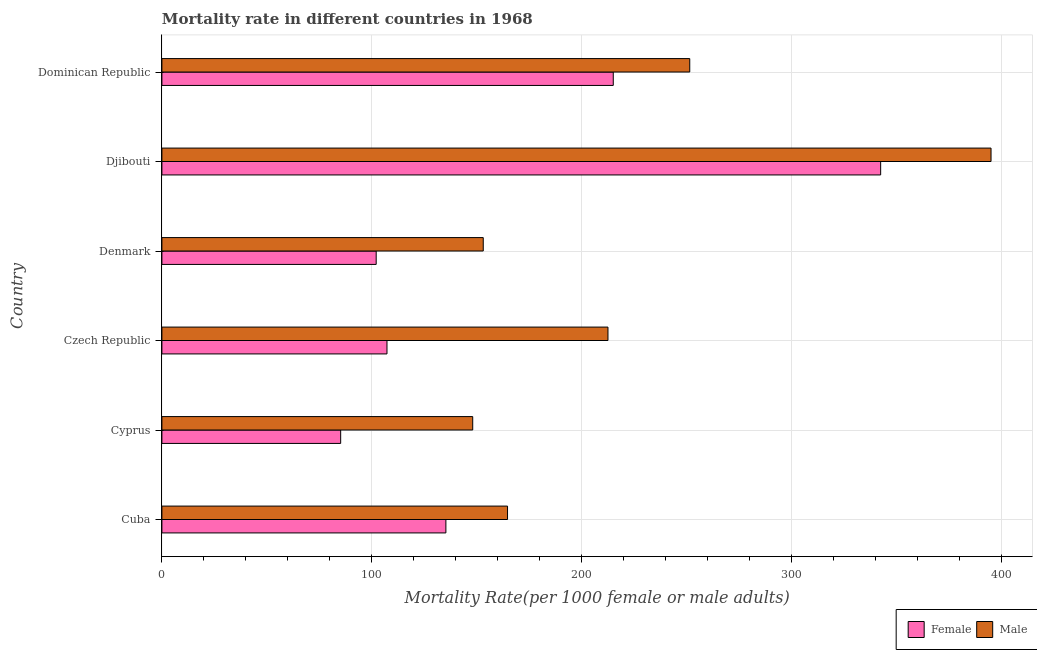How many different coloured bars are there?
Your answer should be compact. 2. How many bars are there on the 5th tick from the bottom?
Make the answer very short. 2. What is the label of the 6th group of bars from the top?
Your answer should be compact. Cuba. In how many cases, is the number of bars for a given country not equal to the number of legend labels?
Provide a short and direct response. 0. What is the female mortality rate in Dominican Republic?
Your answer should be compact. 215.01. Across all countries, what is the maximum female mortality rate?
Your answer should be very brief. 342.39. Across all countries, what is the minimum male mortality rate?
Provide a short and direct response. 148.06. In which country was the female mortality rate maximum?
Provide a short and direct response. Djibouti. In which country was the female mortality rate minimum?
Offer a terse response. Cyprus. What is the total female mortality rate in the graph?
Provide a short and direct response. 987.14. What is the difference between the female mortality rate in Denmark and that in Dominican Republic?
Offer a terse response. -112.94. What is the difference between the female mortality rate in Cyprus and the male mortality rate in Djibouti?
Your answer should be very brief. -309.81. What is the average female mortality rate per country?
Make the answer very short. 164.52. What is the difference between the male mortality rate and female mortality rate in Dominican Republic?
Your response must be concise. 36.43. In how many countries, is the male mortality rate greater than 360 ?
Offer a very short reply. 1. What is the ratio of the male mortality rate in Cyprus to that in Czech Republic?
Ensure brevity in your answer.  0.7. Is the female mortality rate in Cyprus less than that in Czech Republic?
Provide a succinct answer. Yes. Is the difference between the male mortality rate in Czech Republic and Djibouti greater than the difference between the female mortality rate in Czech Republic and Djibouti?
Keep it short and to the point. Yes. What is the difference between the highest and the second highest female mortality rate?
Keep it short and to the point. 127.38. What is the difference between the highest and the lowest male mortality rate?
Offer a terse response. 246.91. In how many countries, is the male mortality rate greater than the average male mortality rate taken over all countries?
Keep it short and to the point. 2. Is the sum of the female mortality rate in Cyprus and Djibouti greater than the maximum male mortality rate across all countries?
Keep it short and to the point. Yes. What does the 2nd bar from the bottom in Dominican Republic represents?
Offer a very short reply. Male. Are all the bars in the graph horizontal?
Your answer should be very brief. Yes. How many countries are there in the graph?
Make the answer very short. 6. What is the difference between two consecutive major ticks on the X-axis?
Offer a terse response. 100. Are the values on the major ticks of X-axis written in scientific E-notation?
Provide a succinct answer. No. Does the graph contain grids?
Your answer should be compact. Yes. How many legend labels are there?
Keep it short and to the point. 2. What is the title of the graph?
Your answer should be very brief. Mortality rate in different countries in 1968. Does "Under-5(female)" appear as one of the legend labels in the graph?
Ensure brevity in your answer.  No. What is the label or title of the X-axis?
Offer a very short reply. Mortality Rate(per 1000 female or male adults). What is the label or title of the Y-axis?
Your answer should be compact. Country. What is the Mortality Rate(per 1000 female or male adults) in Female in Cuba?
Provide a succinct answer. 135.28. What is the Mortality Rate(per 1000 female or male adults) in Male in Cuba?
Your answer should be very brief. 164.65. What is the Mortality Rate(per 1000 female or male adults) of Female in Cyprus?
Ensure brevity in your answer.  85.16. What is the Mortality Rate(per 1000 female or male adults) in Male in Cyprus?
Keep it short and to the point. 148.06. What is the Mortality Rate(per 1000 female or male adults) in Female in Czech Republic?
Ensure brevity in your answer.  107.22. What is the Mortality Rate(per 1000 female or male adults) in Male in Czech Republic?
Give a very brief answer. 212.49. What is the Mortality Rate(per 1000 female or male adults) of Female in Denmark?
Provide a short and direct response. 102.08. What is the Mortality Rate(per 1000 female or male adults) of Male in Denmark?
Your response must be concise. 153.08. What is the Mortality Rate(per 1000 female or male adults) in Female in Djibouti?
Your answer should be very brief. 342.39. What is the Mortality Rate(per 1000 female or male adults) of Male in Djibouti?
Provide a succinct answer. 394.97. What is the Mortality Rate(per 1000 female or male adults) in Female in Dominican Republic?
Give a very brief answer. 215.01. What is the Mortality Rate(per 1000 female or male adults) in Male in Dominican Republic?
Your answer should be compact. 251.44. Across all countries, what is the maximum Mortality Rate(per 1000 female or male adults) of Female?
Make the answer very short. 342.39. Across all countries, what is the maximum Mortality Rate(per 1000 female or male adults) of Male?
Provide a short and direct response. 394.97. Across all countries, what is the minimum Mortality Rate(per 1000 female or male adults) of Female?
Keep it short and to the point. 85.16. Across all countries, what is the minimum Mortality Rate(per 1000 female or male adults) of Male?
Offer a very short reply. 148.06. What is the total Mortality Rate(per 1000 female or male adults) of Female in the graph?
Offer a terse response. 987.14. What is the total Mortality Rate(per 1000 female or male adults) in Male in the graph?
Your answer should be compact. 1324.7. What is the difference between the Mortality Rate(per 1000 female or male adults) of Female in Cuba and that in Cyprus?
Keep it short and to the point. 50.12. What is the difference between the Mortality Rate(per 1000 female or male adults) of Male in Cuba and that in Cyprus?
Provide a succinct answer. 16.59. What is the difference between the Mortality Rate(per 1000 female or male adults) of Female in Cuba and that in Czech Republic?
Make the answer very short. 28.06. What is the difference between the Mortality Rate(per 1000 female or male adults) in Male in Cuba and that in Czech Republic?
Provide a succinct answer. -47.84. What is the difference between the Mortality Rate(per 1000 female or male adults) in Female in Cuba and that in Denmark?
Offer a very short reply. 33.2. What is the difference between the Mortality Rate(per 1000 female or male adults) in Male in Cuba and that in Denmark?
Make the answer very short. 11.57. What is the difference between the Mortality Rate(per 1000 female or male adults) in Female in Cuba and that in Djibouti?
Ensure brevity in your answer.  -207.11. What is the difference between the Mortality Rate(per 1000 female or male adults) in Male in Cuba and that in Djibouti?
Make the answer very short. -230.32. What is the difference between the Mortality Rate(per 1000 female or male adults) in Female in Cuba and that in Dominican Republic?
Provide a short and direct response. -79.73. What is the difference between the Mortality Rate(per 1000 female or male adults) of Male in Cuba and that in Dominican Republic?
Provide a succinct answer. -86.8. What is the difference between the Mortality Rate(per 1000 female or male adults) of Female in Cyprus and that in Czech Republic?
Offer a terse response. -22.07. What is the difference between the Mortality Rate(per 1000 female or male adults) in Male in Cyprus and that in Czech Republic?
Your answer should be very brief. -64.43. What is the difference between the Mortality Rate(per 1000 female or male adults) of Female in Cyprus and that in Denmark?
Offer a terse response. -16.92. What is the difference between the Mortality Rate(per 1000 female or male adults) of Male in Cyprus and that in Denmark?
Provide a succinct answer. -5.02. What is the difference between the Mortality Rate(per 1000 female or male adults) of Female in Cyprus and that in Djibouti?
Ensure brevity in your answer.  -257.23. What is the difference between the Mortality Rate(per 1000 female or male adults) of Male in Cyprus and that in Djibouti?
Your answer should be very brief. -246.91. What is the difference between the Mortality Rate(per 1000 female or male adults) in Female in Cyprus and that in Dominican Republic?
Your answer should be very brief. -129.86. What is the difference between the Mortality Rate(per 1000 female or male adults) of Male in Cyprus and that in Dominican Republic?
Ensure brevity in your answer.  -103.39. What is the difference between the Mortality Rate(per 1000 female or male adults) of Female in Czech Republic and that in Denmark?
Provide a short and direct response. 5.15. What is the difference between the Mortality Rate(per 1000 female or male adults) in Male in Czech Republic and that in Denmark?
Make the answer very short. 59.41. What is the difference between the Mortality Rate(per 1000 female or male adults) in Female in Czech Republic and that in Djibouti?
Your answer should be compact. -235.17. What is the difference between the Mortality Rate(per 1000 female or male adults) of Male in Czech Republic and that in Djibouti?
Provide a succinct answer. -182.48. What is the difference between the Mortality Rate(per 1000 female or male adults) in Female in Czech Republic and that in Dominican Republic?
Provide a succinct answer. -107.79. What is the difference between the Mortality Rate(per 1000 female or male adults) of Male in Czech Republic and that in Dominican Republic?
Ensure brevity in your answer.  -38.95. What is the difference between the Mortality Rate(per 1000 female or male adults) in Female in Denmark and that in Djibouti?
Your answer should be compact. -240.31. What is the difference between the Mortality Rate(per 1000 female or male adults) of Male in Denmark and that in Djibouti?
Ensure brevity in your answer.  -241.89. What is the difference between the Mortality Rate(per 1000 female or male adults) of Female in Denmark and that in Dominican Republic?
Ensure brevity in your answer.  -112.94. What is the difference between the Mortality Rate(per 1000 female or male adults) of Male in Denmark and that in Dominican Republic?
Provide a short and direct response. -98.36. What is the difference between the Mortality Rate(per 1000 female or male adults) in Female in Djibouti and that in Dominican Republic?
Offer a very short reply. 127.38. What is the difference between the Mortality Rate(per 1000 female or male adults) in Male in Djibouti and that in Dominican Republic?
Give a very brief answer. 143.53. What is the difference between the Mortality Rate(per 1000 female or male adults) of Female in Cuba and the Mortality Rate(per 1000 female or male adults) of Male in Cyprus?
Your answer should be very brief. -12.78. What is the difference between the Mortality Rate(per 1000 female or male adults) of Female in Cuba and the Mortality Rate(per 1000 female or male adults) of Male in Czech Republic?
Ensure brevity in your answer.  -77.21. What is the difference between the Mortality Rate(per 1000 female or male adults) of Female in Cuba and the Mortality Rate(per 1000 female or male adults) of Male in Denmark?
Your answer should be very brief. -17.8. What is the difference between the Mortality Rate(per 1000 female or male adults) in Female in Cuba and the Mortality Rate(per 1000 female or male adults) in Male in Djibouti?
Keep it short and to the point. -259.69. What is the difference between the Mortality Rate(per 1000 female or male adults) of Female in Cuba and the Mortality Rate(per 1000 female or male adults) of Male in Dominican Republic?
Offer a terse response. -116.16. What is the difference between the Mortality Rate(per 1000 female or male adults) of Female in Cyprus and the Mortality Rate(per 1000 female or male adults) of Male in Czech Republic?
Your answer should be compact. -127.33. What is the difference between the Mortality Rate(per 1000 female or male adults) of Female in Cyprus and the Mortality Rate(per 1000 female or male adults) of Male in Denmark?
Give a very brief answer. -67.93. What is the difference between the Mortality Rate(per 1000 female or male adults) of Female in Cyprus and the Mortality Rate(per 1000 female or male adults) of Male in Djibouti?
Give a very brief answer. -309.81. What is the difference between the Mortality Rate(per 1000 female or male adults) in Female in Cyprus and the Mortality Rate(per 1000 female or male adults) in Male in Dominican Republic?
Offer a very short reply. -166.29. What is the difference between the Mortality Rate(per 1000 female or male adults) in Female in Czech Republic and the Mortality Rate(per 1000 female or male adults) in Male in Denmark?
Your answer should be very brief. -45.86. What is the difference between the Mortality Rate(per 1000 female or male adults) in Female in Czech Republic and the Mortality Rate(per 1000 female or male adults) in Male in Djibouti?
Offer a terse response. -287.75. What is the difference between the Mortality Rate(per 1000 female or male adults) of Female in Czech Republic and the Mortality Rate(per 1000 female or male adults) of Male in Dominican Republic?
Offer a terse response. -144.22. What is the difference between the Mortality Rate(per 1000 female or male adults) in Female in Denmark and the Mortality Rate(per 1000 female or male adults) in Male in Djibouti?
Ensure brevity in your answer.  -292.89. What is the difference between the Mortality Rate(per 1000 female or male adults) of Female in Denmark and the Mortality Rate(per 1000 female or male adults) of Male in Dominican Republic?
Your response must be concise. -149.37. What is the difference between the Mortality Rate(per 1000 female or male adults) of Female in Djibouti and the Mortality Rate(per 1000 female or male adults) of Male in Dominican Republic?
Give a very brief answer. 90.95. What is the average Mortality Rate(per 1000 female or male adults) of Female per country?
Provide a succinct answer. 164.52. What is the average Mortality Rate(per 1000 female or male adults) in Male per country?
Keep it short and to the point. 220.78. What is the difference between the Mortality Rate(per 1000 female or male adults) of Female and Mortality Rate(per 1000 female or male adults) of Male in Cuba?
Make the answer very short. -29.37. What is the difference between the Mortality Rate(per 1000 female or male adults) in Female and Mortality Rate(per 1000 female or male adults) in Male in Cyprus?
Offer a terse response. -62.9. What is the difference between the Mortality Rate(per 1000 female or male adults) of Female and Mortality Rate(per 1000 female or male adults) of Male in Czech Republic?
Your answer should be very brief. -105.27. What is the difference between the Mortality Rate(per 1000 female or male adults) of Female and Mortality Rate(per 1000 female or male adults) of Male in Denmark?
Keep it short and to the point. -51.01. What is the difference between the Mortality Rate(per 1000 female or male adults) in Female and Mortality Rate(per 1000 female or male adults) in Male in Djibouti?
Give a very brief answer. -52.58. What is the difference between the Mortality Rate(per 1000 female or male adults) in Female and Mortality Rate(per 1000 female or male adults) in Male in Dominican Republic?
Make the answer very short. -36.43. What is the ratio of the Mortality Rate(per 1000 female or male adults) in Female in Cuba to that in Cyprus?
Ensure brevity in your answer.  1.59. What is the ratio of the Mortality Rate(per 1000 female or male adults) of Male in Cuba to that in Cyprus?
Offer a very short reply. 1.11. What is the ratio of the Mortality Rate(per 1000 female or male adults) of Female in Cuba to that in Czech Republic?
Give a very brief answer. 1.26. What is the ratio of the Mortality Rate(per 1000 female or male adults) of Male in Cuba to that in Czech Republic?
Keep it short and to the point. 0.77. What is the ratio of the Mortality Rate(per 1000 female or male adults) in Female in Cuba to that in Denmark?
Offer a very short reply. 1.33. What is the ratio of the Mortality Rate(per 1000 female or male adults) in Male in Cuba to that in Denmark?
Make the answer very short. 1.08. What is the ratio of the Mortality Rate(per 1000 female or male adults) of Female in Cuba to that in Djibouti?
Your answer should be very brief. 0.4. What is the ratio of the Mortality Rate(per 1000 female or male adults) of Male in Cuba to that in Djibouti?
Keep it short and to the point. 0.42. What is the ratio of the Mortality Rate(per 1000 female or male adults) in Female in Cuba to that in Dominican Republic?
Make the answer very short. 0.63. What is the ratio of the Mortality Rate(per 1000 female or male adults) of Male in Cuba to that in Dominican Republic?
Offer a very short reply. 0.65. What is the ratio of the Mortality Rate(per 1000 female or male adults) in Female in Cyprus to that in Czech Republic?
Your answer should be compact. 0.79. What is the ratio of the Mortality Rate(per 1000 female or male adults) of Male in Cyprus to that in Czech Republic?
Your answer should be compact. 0.7. What is the ratio of the Mortality Rate(per 1000 female or male adults) in Female in Cyprus to that in Denmark?
Keep it short and to the point. 0.83. What is the ratio of the Mortality Rate(per 1000 female or male adults) in Male in Cyprus to that in Denmark?
Your response must be concise. 0.97. What is the ratio of the Mortality Rate(per 1000 female or male adults) in Female in Cyprus to that in Djibouti?
Make the answer very short. 0.25. What is the ratio of the Mortality Rate(per 1000 female or male adults) in Male in Cyprus to that in Djibouti?
Keep it short and to the point. 0.37. What is the ratio of the Mortality Rate(per 1000 female or male adults) in Female in Cyprus to that in Dominican Republic?
Your answer should be compact. 0.4. What is the ratio of the Mortality Rate(per 1000 female or male adults) in Male in Cyprus to that in Dominican Republic?
Offer a very short reply. 0.59. What is the ratio of the Mortality Rate(per 1000 female or male adults) of Female in Czech Republic to that in Denmark?
Offer a terse response. 1.05. What is the ratio of the Mortality Rate(per 1000 female or male adults) of Male in Czech Republic to that in Denmark?
Offer a terse response. 1.39. What is the ratio of the Mortality Rate(per 1000 female or male adults) of Female in Czech Republic to that in Djibouti?
Make the answer very short. 0.31. What is the ratio of the Mortality Rate(per 1000 female or male adults) in Male in Czech Republic to that in Djibouti?
Provide a short and direct response. 0.54. What is the ratio of the Mortality Rate(per 1000 female or male adults) of Female in Czech Republic to that in Dominican Republic?
Keep it short and to the point. 0.5. What is the ratio of the Mortality Rate(per 1000 female or male adults) in Male in Czech Republic to that in Dominican Republic?
Your answer should be very brief. 0.85. What is the ratio of the Mortality Rate(per 1000 female or male adults) in Female in Denmark to that in Djibouti?
Provide a succinct answer. 0.3. What is the ratio of the Mortality Rate(per 1000 female or male adults) in Male in Denmark to that in Djibouti?
Give a very brief answer. 0.39. What is the ratio of the Mortality Rate(per 1000 female or male adults) in Female in Denmark to that in Dominican Republic?
Offer a very short reply. 0.47. What is the ratio of the Mortality Rate(per 1000 female or male adults) of Male in Denmark to that in Dominican Republic?
Your answer should be very brief. 0.61. What is the ratio of the Mortality Rate(per 1000 female or male adults) in Female in Djibouti to that in Dominican Republic?
Your answer should be very brief. 1.59. What is the ratio of the Mortality Rate(per 1000 female or male adults) in Male in Djibouti to that in Dominican Republic?
Your answer should be compact. 1.57. What is the difference between the highest and the second highest Mortality Rate(per 1000 female or male adults) in Female?
Offer a very short reply. 127.38. What is the difference between the highest and the second highest Mortality Rate(per 1000 female or male adults) in Male?
Ensure brevity in your answer.  143.53. What is the difference between the highest and the lowest Mortality Rate(per 1000 female or male adults) in Female?
Your response must be concise. 257.23. What is the difference between the highest and the lowest Mortality Rate(per 1000 female or male adults) of Male?
Offer a terse response. 246.91. 